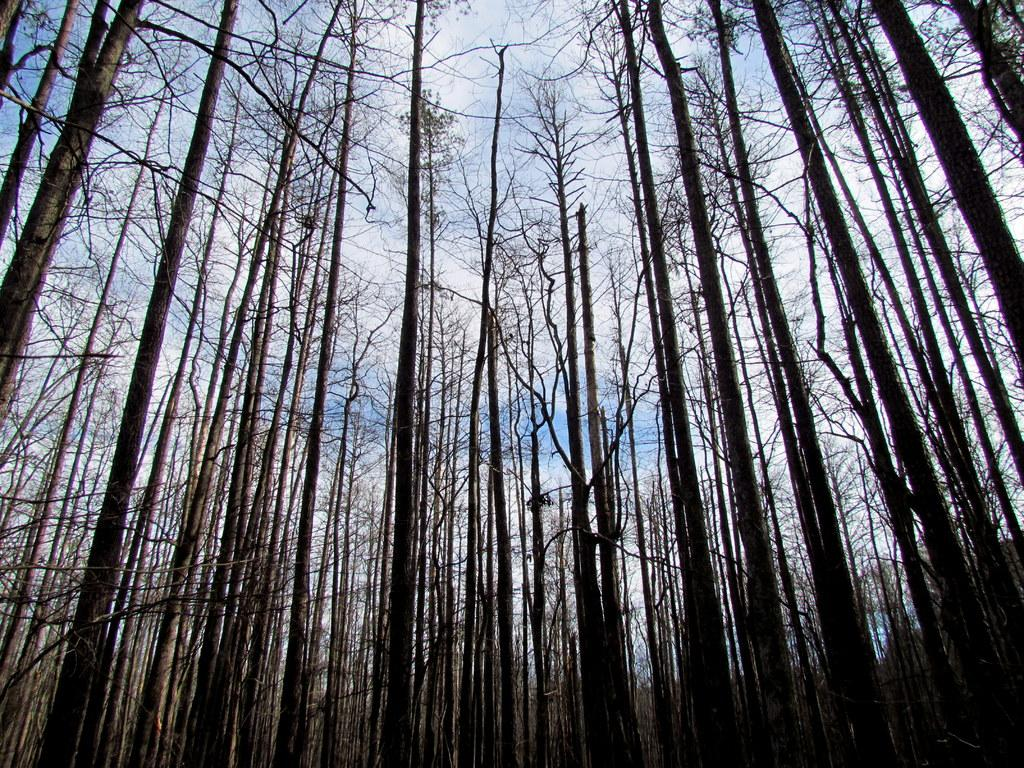What type of vegetation can be seen in the image? There are trees in the image. What can be seen in the sky in the image? There are clouds in the image. What type of nerve can be seen in the image? There is no nerve present in the image; it features trees and clouds. How long does it take for the minute hand to move in the image? There is no clock or time-related element present in the image, so it's not possible to determine the movement of a minute hand. 